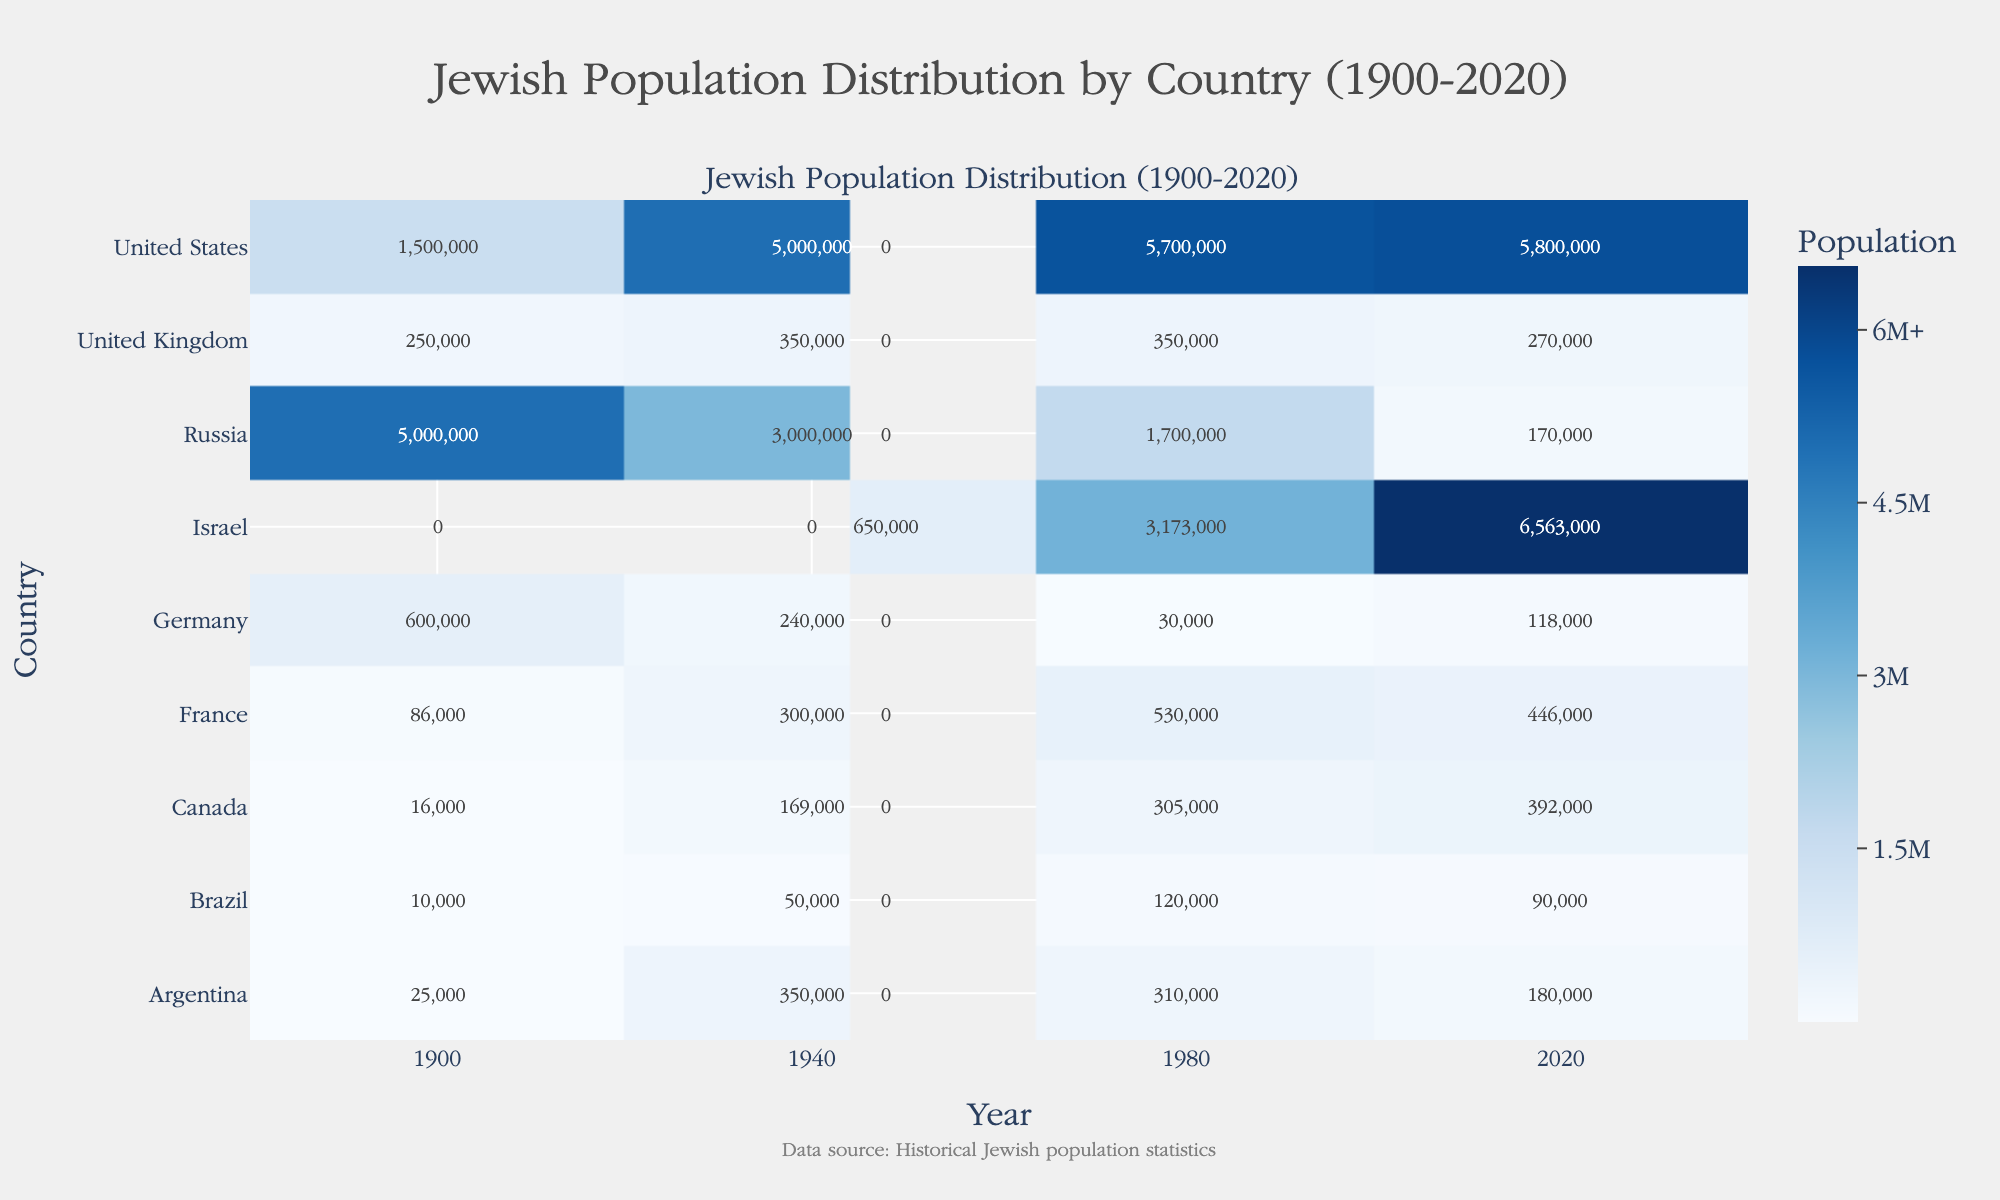What's the title of the heatmap? The title is displayed at the top of the heatmap. It reads, "Jewish Population Distribution by Country (1900-2020)."
Answer: Jewish Population Distribution by Country (1900-2020) Which country had the largest Jewish population in 2020? By examining the heatmap, we can observe that the highest value in the 2020 column corresponds to Israel, with a population of 6,563,000.
Answer: Israel Compare the Jewish population of the United States and Israel in 1940. Which country had a higher population? In the 1940 column, the United States shows a Jewish population of 5,000,000, whereas Israel (which did not officially exist in 1940) shows no value. Hence, the United States had a higher population.
Answer: United States What is the trend observed for the Jewish population in Germany from 1900 to 2020? Looking at the values for Germany across the years, we see a decline: 600,000 in 1900, 240,000 in 1940, 30,000 in 1980, and 118,000 in 2020. This indicates an overall declining trend, with a slight increase from 1980 to 2020.
Answer: Declining trend Calculate the total Jewish population in Argentina over the considered years (sum of all values for Argentina). Adding the values for Argentina from 1900, 1940, 1980, and 2020: 25,000 + 350,000 + 310,000 + 180,000, we get a total of 865,000.
Answer: 865,000 Which decade shows the most significant increase in the Jewish population of Israel? By comparing the values for Israel: 650,000 in 1948, 3,173,000 in 1980, and 6,563,000 in 2020, the most significant increase is from 1948 to 1980 (650,000 to 3,173,000), an increase of 2,523,000.
Answer: 1948 to 1980 What color represents the highest population values on the heatmap? The colors vary from light blue to dark blue. The highest population values are represented by the darkest shade of blue.
Answer: Dark blue Which country had a constant Jewish population from 1940 to 1980? Observing the values for all countries, the United Kingdom shows consistency, with a Jewish population of 350,000 in both 1940 and 1980.
Answer: United Kingdom How did the Jewish population in Russia change from 1980 to 2020? The Jewish population in Russia decreased from 1,700,000 in 1980 to 170,000 in 2020.
Answer: Decreased Compare the Jewish populations in Canada and Brazil in 1980. Which country had more, and by how much? In 1980, Canada had 305,000, and Brazil had 120,000. The difference is 305,000 - 120,000 = 185,000.
Answer: Canada, by 185,000 